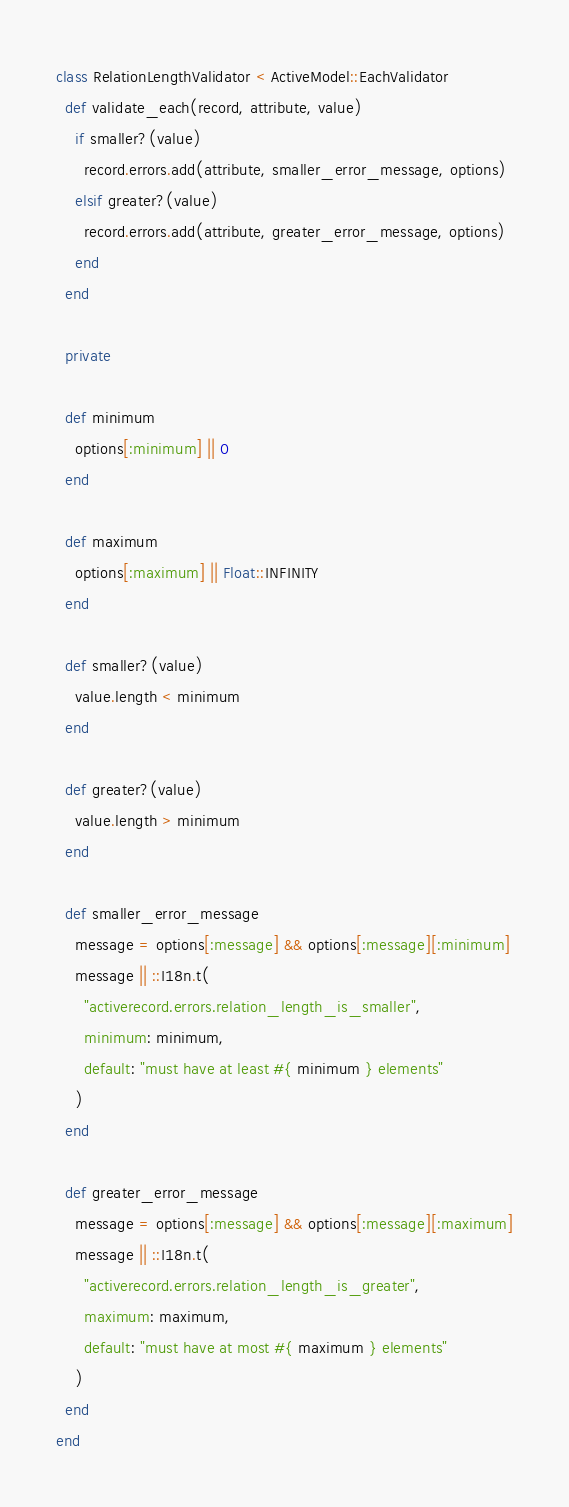<code> <loc_0><loc_0><loc_500><loc_500><_Ruby_>class RelationLengthValidator < ActiveModel::EachValidator
  def validate_each(record, attribute, value)
    if smaller?(value)
      record.errors.add(attribute, smaller_error_message, options)
    elsif greater?(value)
      record.errors.add(attribute, greater_error_message, options)
    end
  end

  private

  def minimum
    options[:minimum] || 0
  end

  def maximum
    options[:maximum] || Float::INFINITY
  end

  def smaller?(value)
    value.length < minimum
  end

  def greater?(value)
    value.length > minimum
  end

  def smaller_error_message
    message = options[:message] && options[:message][:minimum]
    message || ::I18n.t(
      "activerecord.errors.relation_length_is_smaller",
      minimum: minimum,
      default: "must have at least #{ minimum } elements"
    )
  end

  def greater_error_message
    message = options[:message] && options[:message][:maximum]
    message || ::I18n.t(
      "activerecord.errors.relation_length_is_greater",
      maximum: maximum,
      default: "must have at most #{ maximum } elements"
    )
  end
end
</code> 